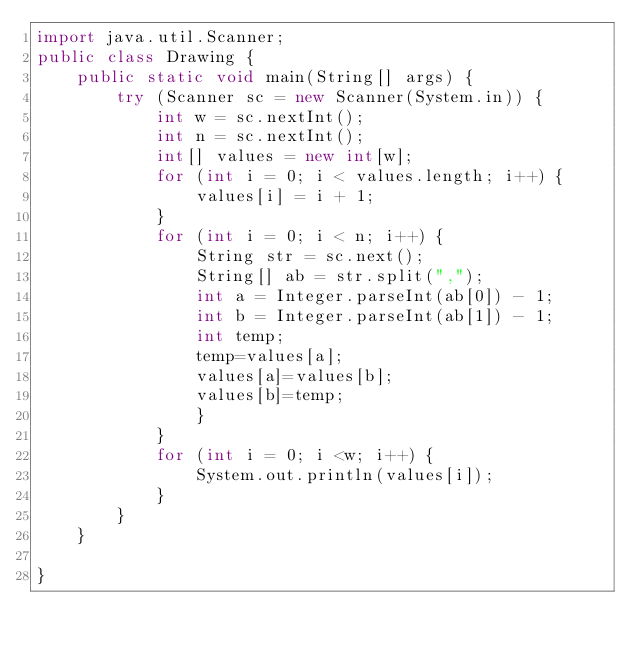<code> <loc_0><loc_0><loc_500><loc_500><_Java_>import java.util.Scanner;
public class Drawing {
    public static void main(String[] args) {
        try (Scanner sc = new Scanner(System.in)) {
            int w = sc.nextInt();
            int n = sc.nextInt();
            int[] values = new int[w];
            for (int i = 0; i < values.length; i++) {
                values[i] = i + 1;
            }
            for (int i = 0; i < n; i++) {
                String str = sc.next();
                String[] ab = str.split(",");
                int a = Integer.parseInt(ab[0]) - 1;
                int b = Integer.parseInt(ab[1]) - 1;
                int temp;
                temp=values[a];
                values[a]=values[b];
                values[b]=temp;
                }
            }
            for (int i = 0; i <w; i++) {
                System.out.println(values[i]);
            }
        }
    }

}
</code> 